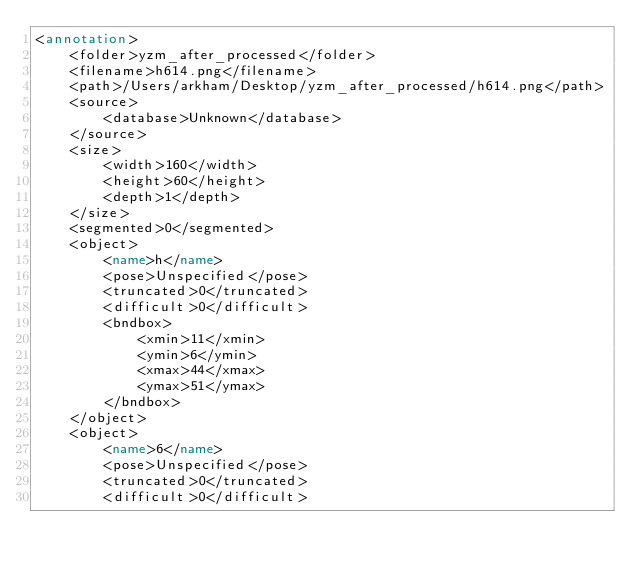Convert code to text. <code><loc_0><loc_0><loc_500><loc_500><_XML_><annotation>
	<folder>yzm_after_processed</folder>
	<filename>h614.png</filename>
	<path>/Users/arkham/Desktop/yzm_after_processed/h614.png</path>
	<source>
		<database>Unknown</database>
	</source>
	<size>
		<width>160</width>
		<height>60</height>
		<depth>1</depth>
	</size>
	<segmented>0</segmented>
	<object>
		<name>h</name>
		<pose>Unspecified</pose>
		<truncated>0</truncated>
		<difficult>0</difficult>
		<bndbox>
			<xmin>11</xmin>
			<ymin>6</ymin>
			<xmax>44</xmax>
			<ymax>51</ymax>
		</bndbox>
	</object>
	<object>
		<name>6</name>
		<pose>Unspecified</pose>
		<truncated>0</truncated>
		<difficult>0</difficult></code> 